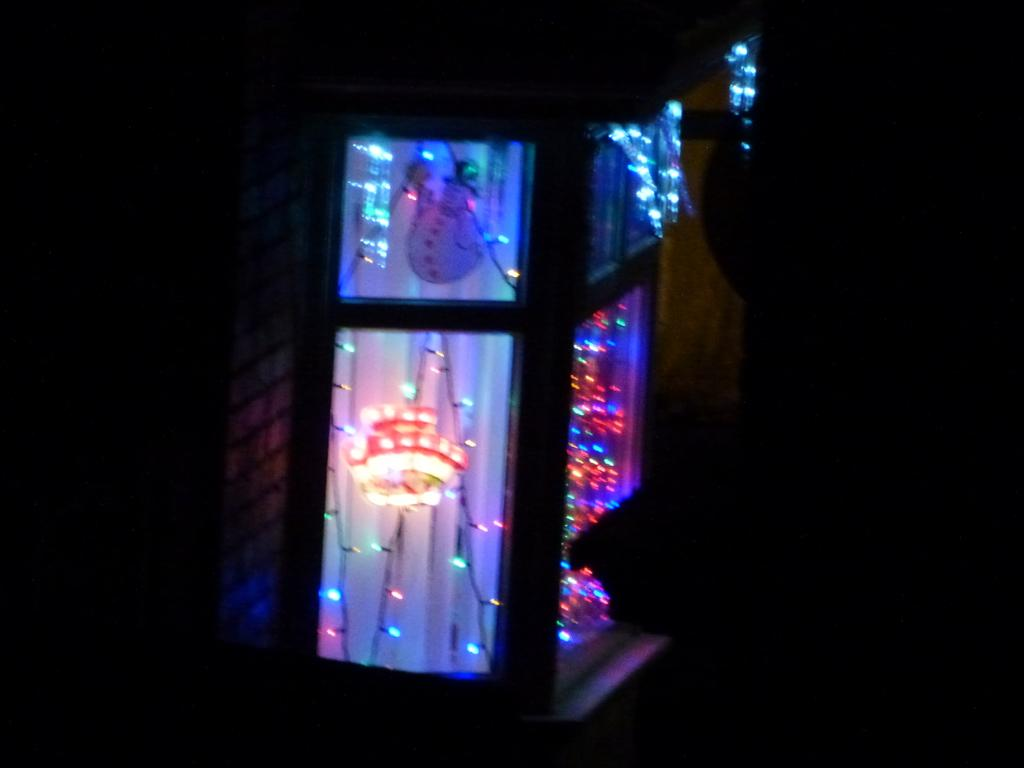What can be seen in the image related to a source of light? Christmas lights are present behind the window in the image. Where are the Christmas lights located in the image? The Christmas lights are located behind the window in the image. What is the taste of the orange nerve in the image? There is no orange or nerve present in the image. 